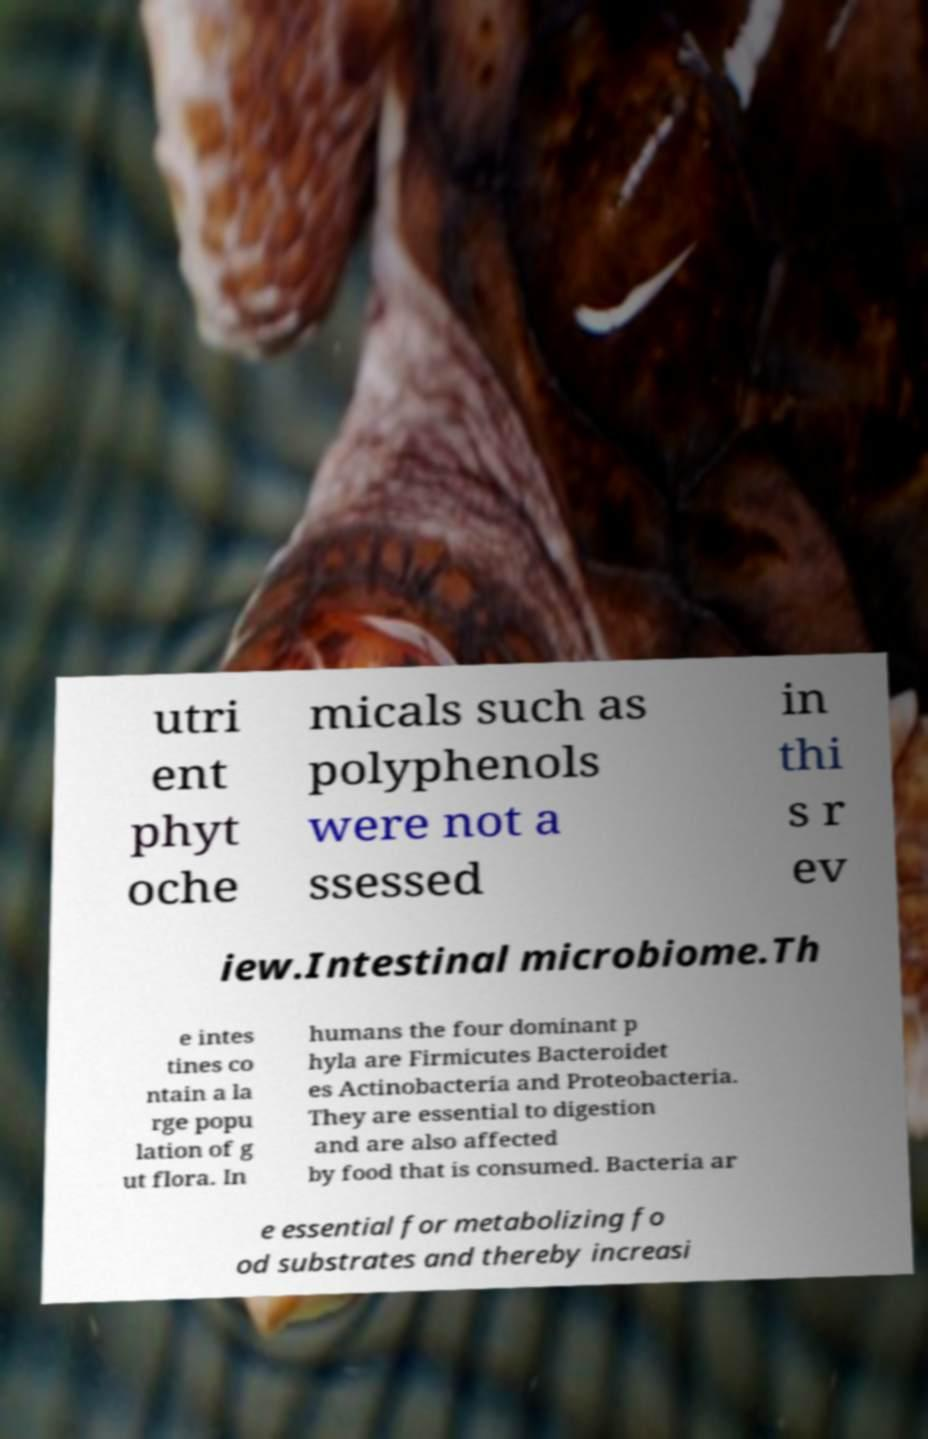Can you accurately transcribe the text from the provided image for me? utri ent phyt oche micals such as polyphenols were not a ssessed in thi s r ev iew.Intestinal microbiome.Th e intes tines co ntain a la rge popu lation of g ut flora. In humans the four dominant p hyla are Firmicutes Bacteroidet es Actinobacteria and Proteobacteria. They are essential to digestion and are also affected by food that is consumed. Bacteria ar e essential for metabolizing fo od substrates and thereby increasi 